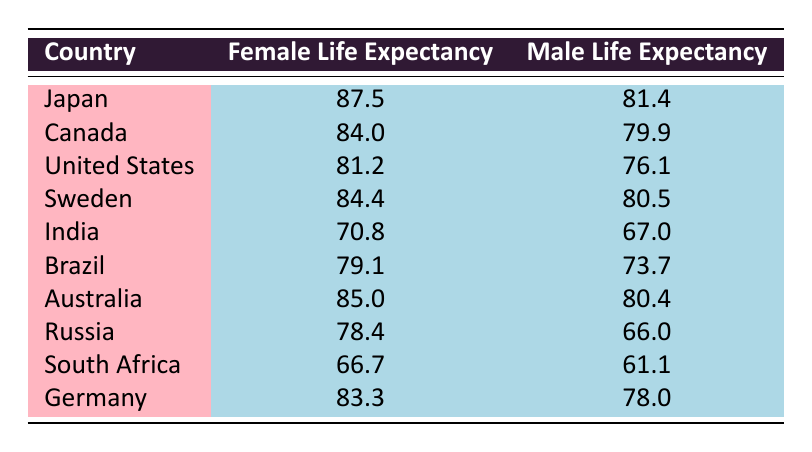What is the female life expectancy in Japan? According to the table, Japan has a female life expectancy of 87.5.
Answer: 87.5 What is the male life expectancy in Russia? From the table, the male life expectancy in Russia is 66.0.
Answer: 66.0 Which country has the highest female life expectancy? The highest female life expectancy is in Japan at 87.5, as shown in the table.
Answer: Japan How much longer do women live compared to men in Canada? In Canada, women live 4.1 years longer than men. This is calculated by subtracting the male life expectancy (79.9) from the female life expectancy (84.0) resulting in 84.0 - 79.9 = 4.1.
Answer: 4.1 Is the male life expectancy greater in Sweden than in the United States? The male life expectancy in Sweden (80.5) is greater than in the United States (76.1), which is apparent by comparing the two values in the table.
Answer: Yes What is the average female life expectancy across all countries listed? To find the average female life expectancy, we add all the female life expectancies: (87.5 + 84.0 + 81.2 + 84.4 + 70.8 + 79.1 + 85.0 + 78.4 + 66.7 + 83.3) = 819.4, and divide by the number of countries (10), resulting in an average of 81.94.
Answer: 81.94 Which country has the lowest female life expectancy? The country with the lowest female life expectancy is South Africa, recorded at 66.7 in the table.
Answer: South Africa In which country do women outlive men by the largest margin? The largest margin where women outlive men is in Russia with a difference of 12.4 years, calculated by subtracting the male life expectancy (66.0) from the female life expectancy (78.4), yielding 78.4 - 66.0 = 12.4.
Answer: Russia What is the gender gap in life expectancy in India? In India, the gender gap in life expectancy is 3.8 years, found by subtracting the male life expectancy (67.0) from the female life expectancy (70.8), giving us 70.8 - 67.0 = 3.8.
Answer: 3.8 